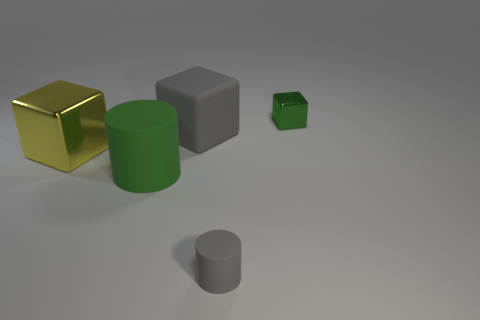Add 2 large cylinders. How many objects exist? 7 Subtract all cylinders. How many objects are left? 3 Subtract all small brown metal balls. Subtract all large things. How many objects are left? 2 Add 4 large metallic things. How many large metallic things are left? 5 Add 4 big purple matte cylinders. How many big purple matte cylinders exist? 4 Subtract 0 purple cylinders. How many objects are left? 5 